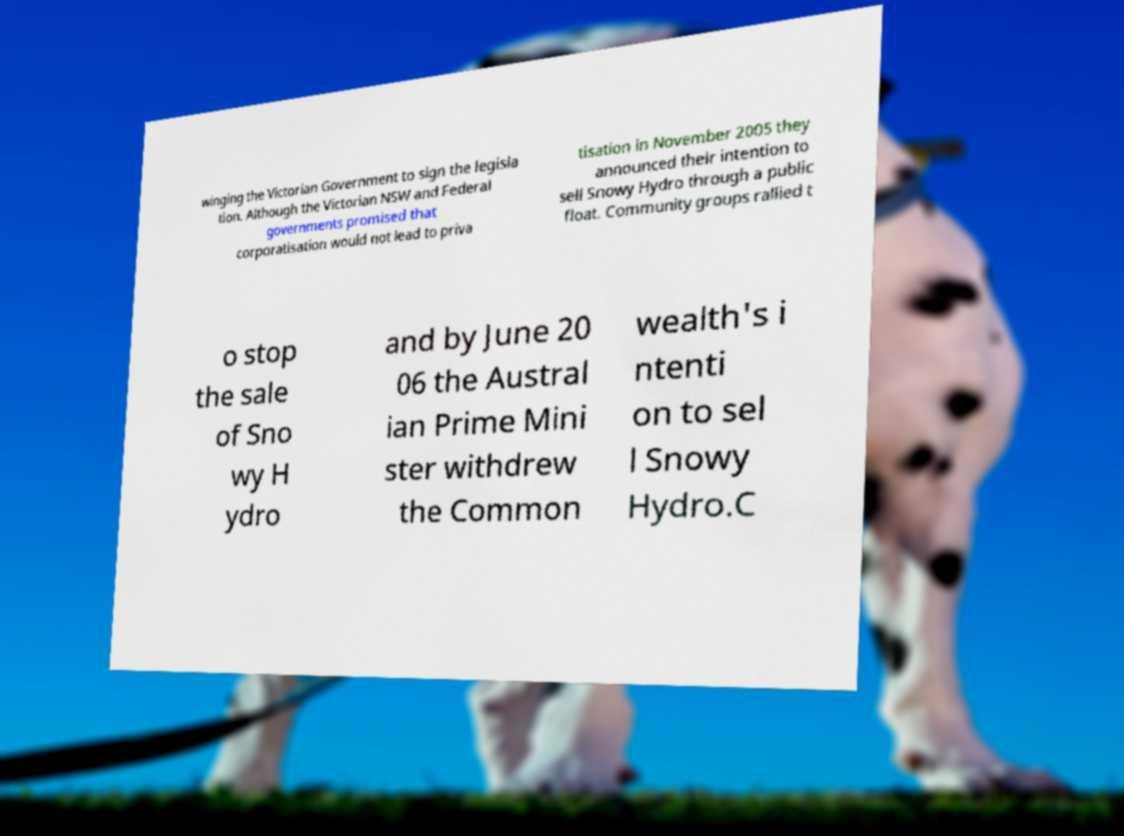Could you assist in decoding the text presented in this image and type it out clearly? winging the Victorian Government to sign the legisla tion. Although the Victorian NSW and Federal governments promised that corporatisation would not lead to priva tisation in November 2005 they announced their intention to sell Snowy Hydro through a public float. Community groups rallied t o stop the sale of Sno wy H ydro and by June 20 06 the Austral ian Prime Mini ster withdrew the Common wealth's i ntenti on to sel l Snowy Hydro.C 